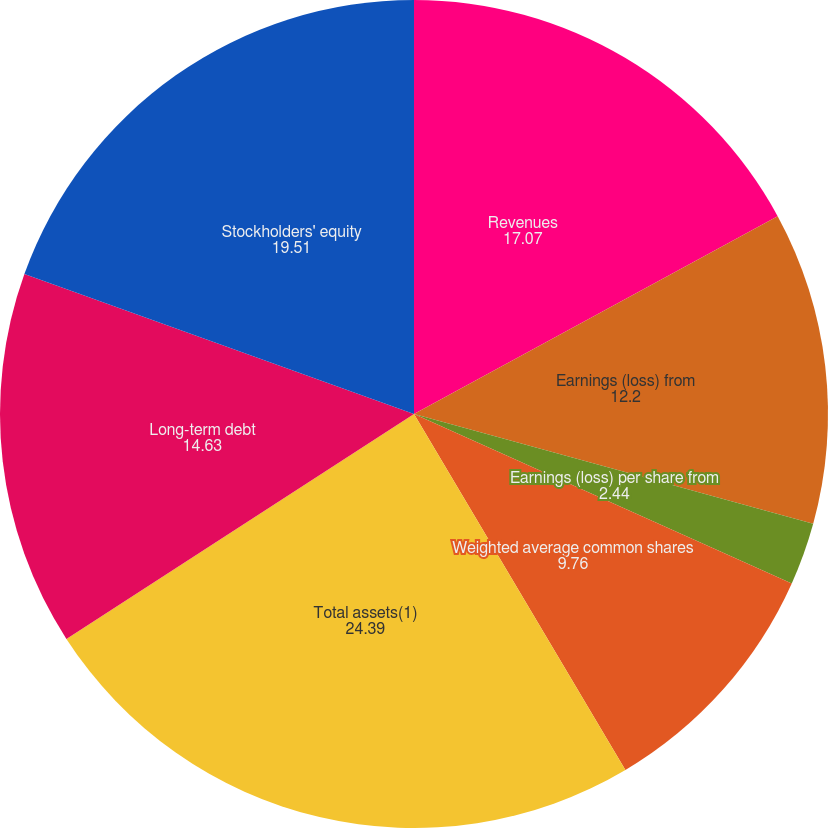Convert chart. <chart><loc_0><loc_0><loc_500><loc_500><pie_chart><fcel>Revenues<fcel>Earnings (loss) from<fcel>Earnings (loss) per share from<fcel>Cash dividends per common<fcel>Weighted average common shares<fcel>Total assets(1)<fcel>Long-term debt<fcel>Stockholders' equity<nl><fcel>17.07%<fcel>12.2%<fcel>2.44%<fcel>0.0%<fcel>9.76%<fcel>24.39%<fcel>14.63%<fcel>19.51%<nl></chart> 